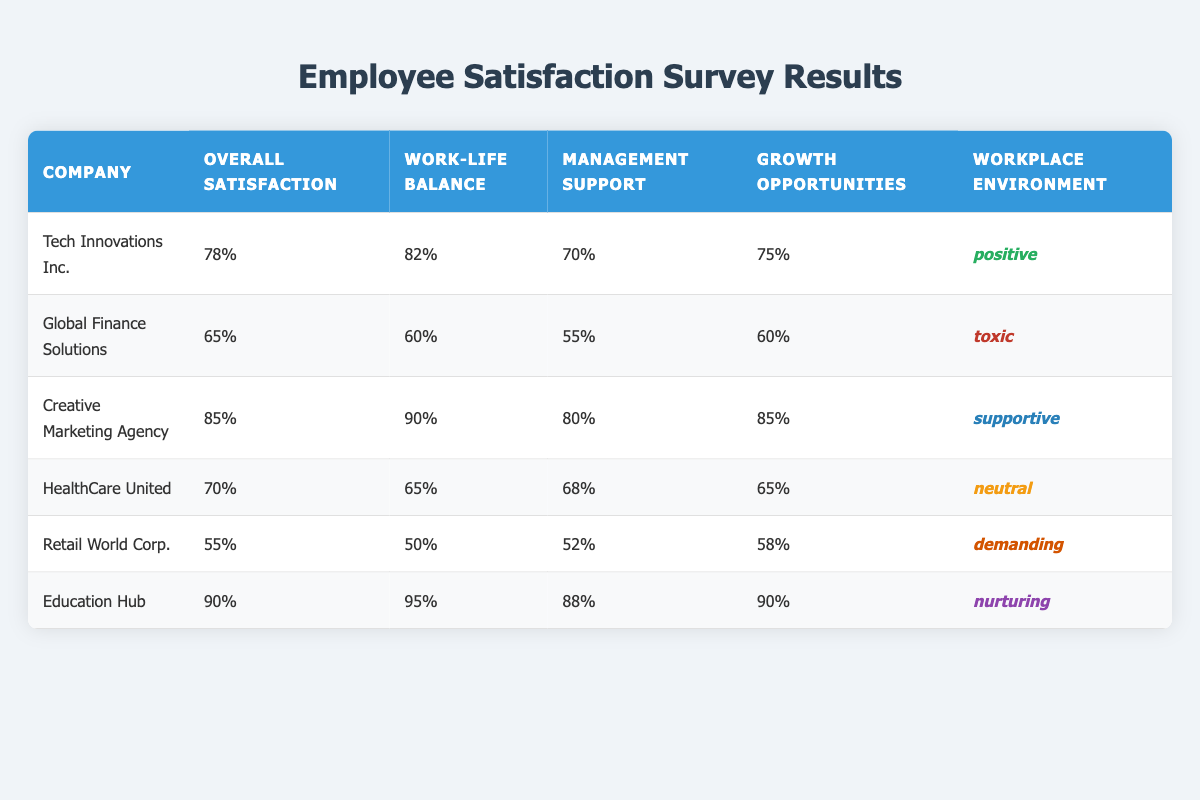What is the highest overall satisfaction score among the companies? By examining the overall satisfaction scores listed for each company, the highest score is 90% for Education Hub.
Answer: 90% Which company has the lowest management support? Looking at the management support values, Global Finance Solutions has the lowest score of 55%.
Answer: 55% What is the average work-life balance score for all companies? To find the average work-life balance score: (82 + 60 + 90 + 65 + 50 + 95) / 6 = 68.33%.
Answer: 68.33% Is the workplace environment of Retail World Corp. considered toxic? The workplace environment for Retail World Corp. is classified as demanding, not toxic, therefore the answer is false.
Answer: False Which company has the best growth opportunities based on the scores? Creative Marketing Agency has the highest score for opportunities for growth at 85%.
Answer: 85% What percentage of companies have a positive workplace environment? There are 6 companies in total, and 3 of them (Tech Innovations Inc., Creative Marketing Agency, Education Hub) have a positive environment. The percentage is (3/6) * 100 = 50%.
Answer: 50% Compare the overall satisfaction score of Global Finance Solutions and HealthCare United. Which one is higher? Global Finance Solutions has an overall satisfaction score of 65%, while HealthCare United has a score of 70%, which is higher.
Answer: HealthCare United What is the difference between the overall satisfaction scores of Education Hub and Retail World Corp.? Education Hub has a score of 90% and Retail World Corp. has 55%. The difference is 90% - 55% = 35%.
Answer: 35% Can you verify if the management support score for Creative Marketing Agency exceeds 75%? Creative Marketing Agency has a management support score of 80%, which does exceed 75%, hence the answer is true.
Answer: True What is the lowest work-life balance score from the provided companies? After reviewing the work-life balance scores, Retail World Corp. has the lowest score at 50%.
Answer: 50% 